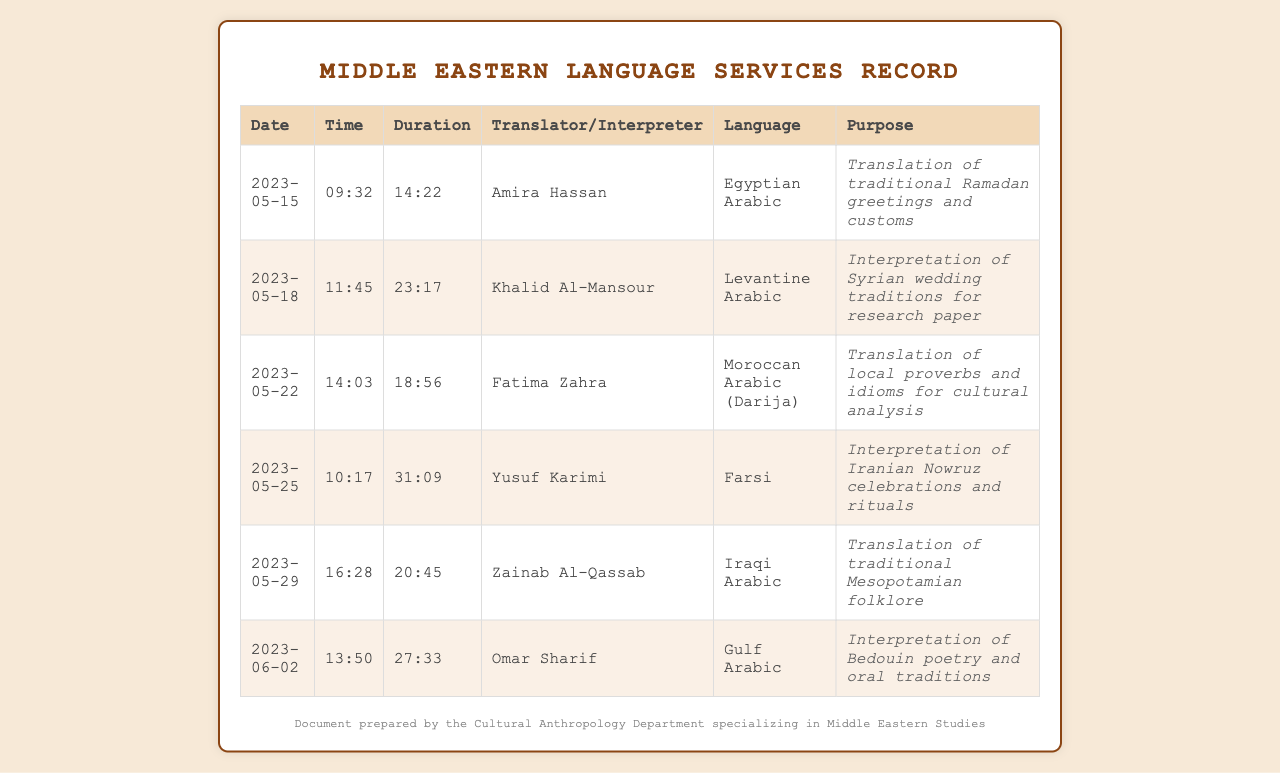what is the purpose of the call on 2023-05-15? The document states that the purpose of the call was the translation of traditional Ramadan greetings and customs.
Answer: Translation of traditional Ramadan greetings and customs who interpreted Syrian wedding traditions? Based on the document, Khalid Al-Mansour was the interpreter for Syrian wedding traditions.
Answer: Khalid Al-Mansour how long was the call with Fatima Zahra? The duration of the call with Fatima Zahra was 18 minutes and 56 seconds.
Answer: 18:56 which language was interpreted on 2023-05-25? The language interpreted on that date was Farsi.
Answer: Farsi which translator handled the cultural analysis of local proverbs? Fatima Zahra was the translator who handled the cultural analysis of local proverbs.
Answer: Fatima Zahra what type of Arabic was the primary focus of the call on 2023-05-29? The primary focus of the call on that date was Iraqi Arabic.
Answer: Iraqi Arabic how many calls were made for interpretation services? The document lists a total of 4 calls made specifically for interpretation services.
Answer: 4 which translator specializes in Bedouin poetry? The translator specializing in Bedouin poetry is Omar Sharif.
Answer: Omar Sharif 